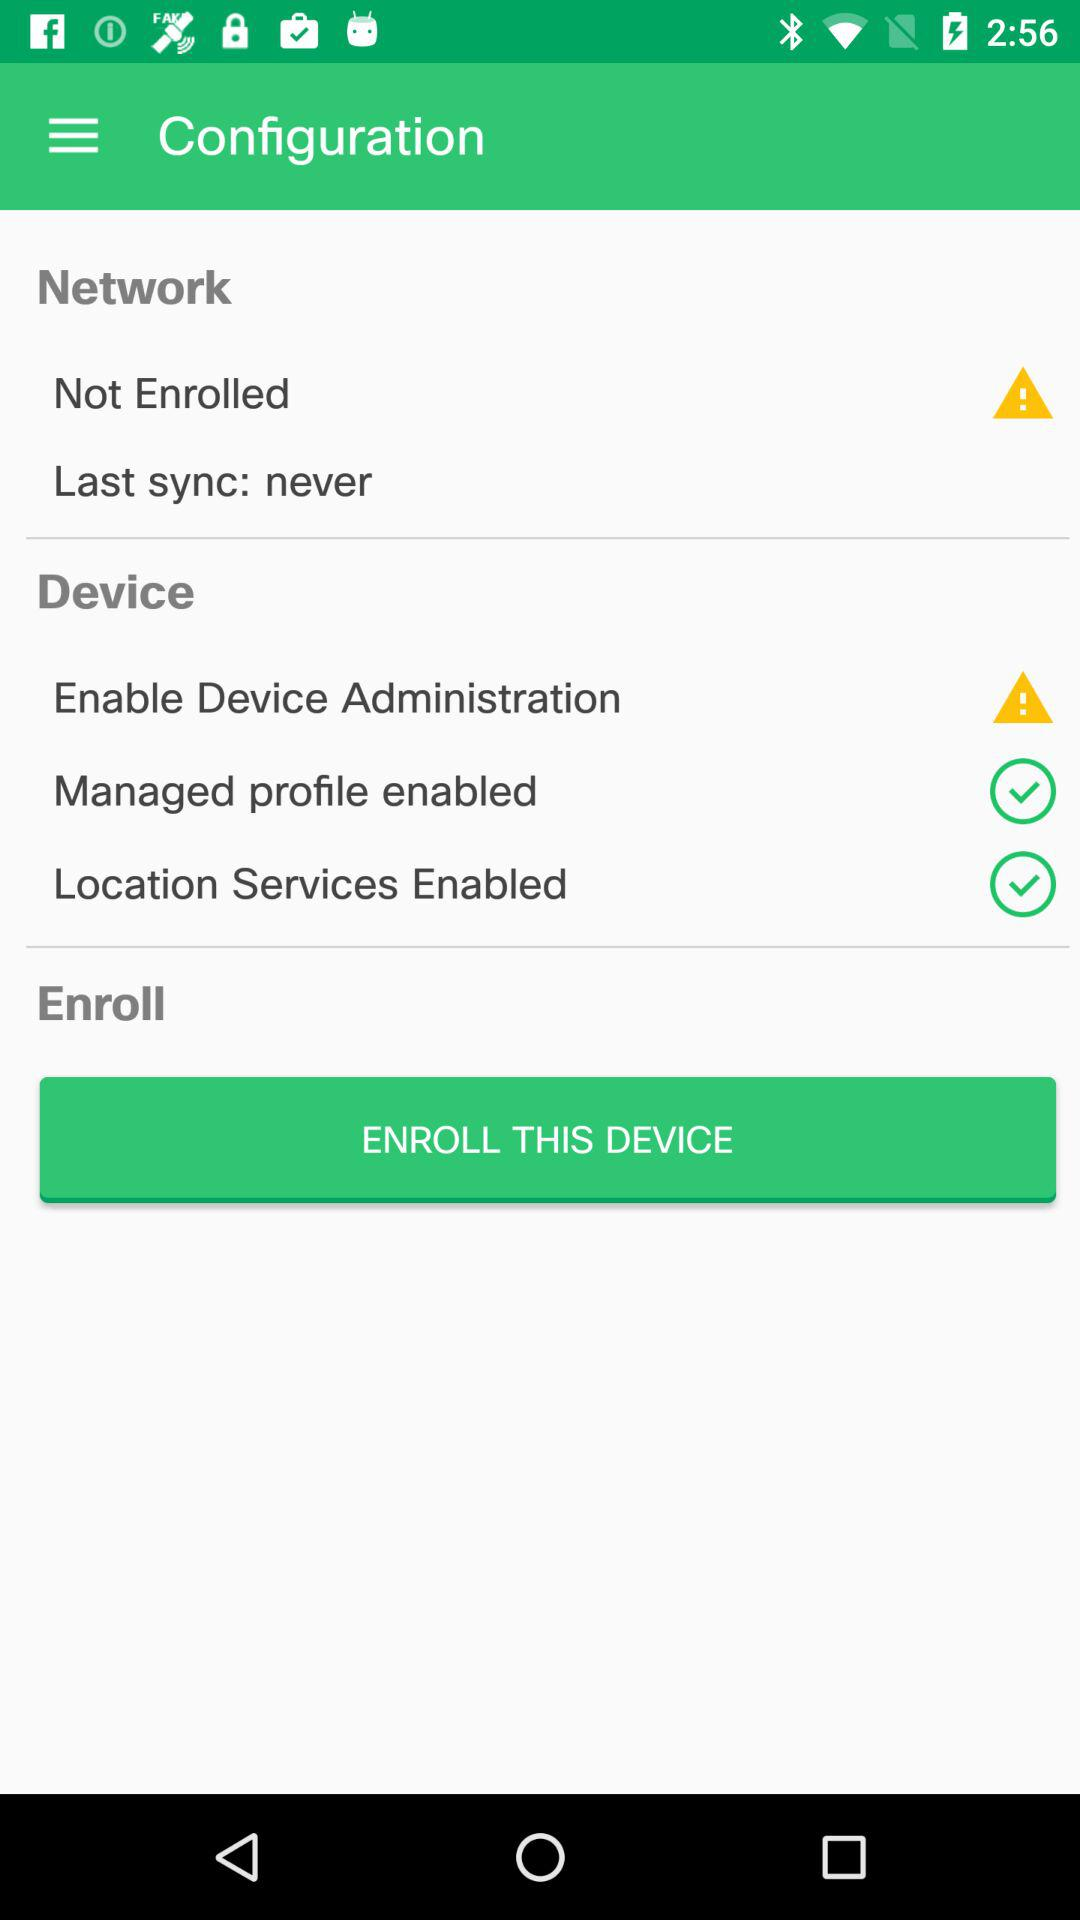How many items in the Device section have a checkbox?
Answer the question using a single word or phrase. 2 